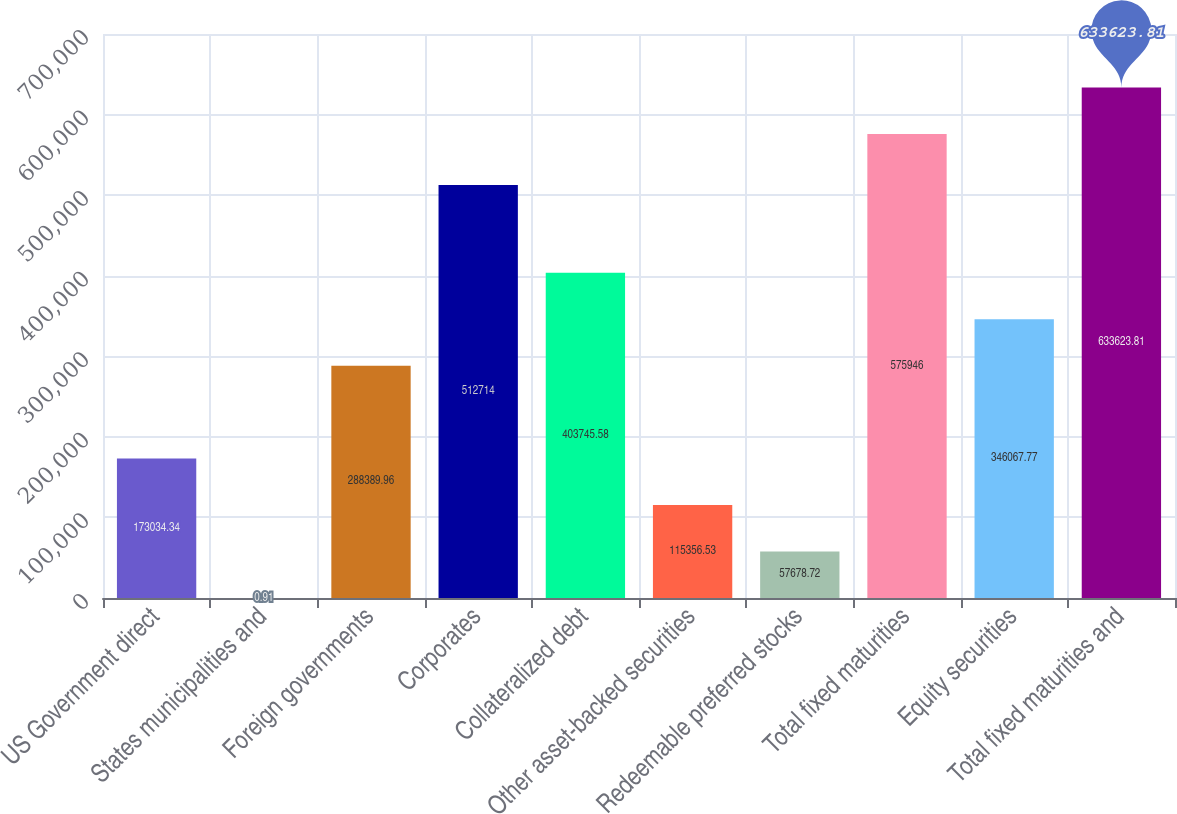Convert chart to OTSL. <chart><loc_0><loc_0><loc_500><loc_500><bar_chart><fcel>US Government direct<fcel>States municipalities and<fcel>Foreign governments<fcel>Corporates<fcel>Collateralized debt<fcel>Other asset-backed securities<fcel>Redeemable preferred stocks<fcel>Total fixed maturities<fcel>Equity securities<fcel>Total fixed maturities and<nl><fcel>173034<fcel>0.91<fcel>288390<fcel>512714<fcel>403746<fcel>115357<fcel>57678.7<fcel>575946<fcel>346068<fcel>633624<nl></chart> 